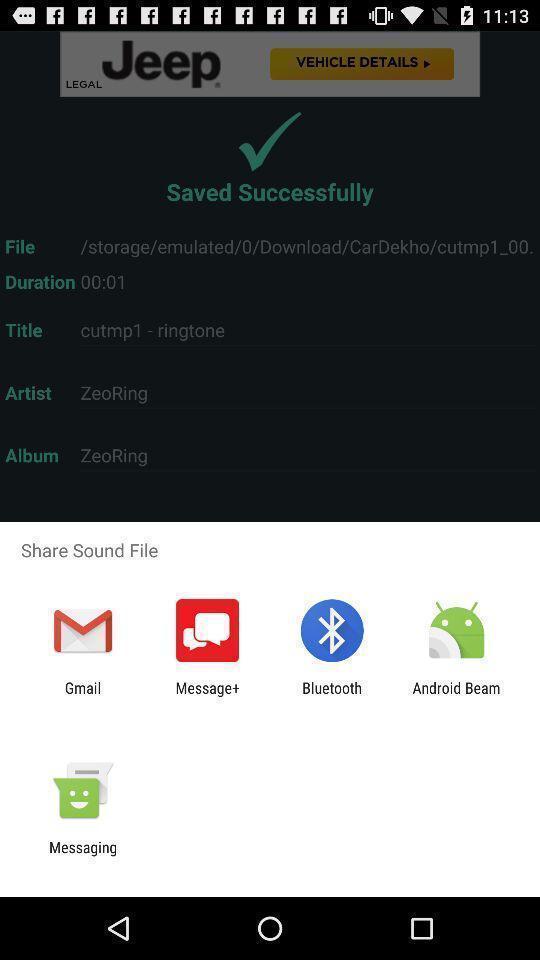Provide a description of this screenshot. Pop-up to share sound file using different apps. 